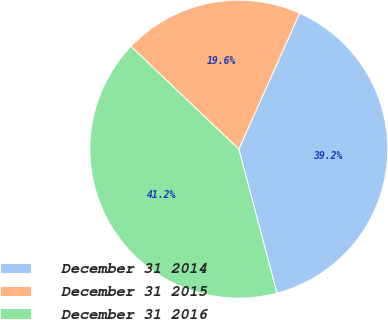Convert chart. <chart><loc_0><loc_0><loc_500><loc_500><pie_chart><fcel>December 31 2014<fcel>December 31 2015<fcel>December 31 2016<nl><fcel>39.18%<fcel>19.59%<fcel>41.24%<nl></chart> 